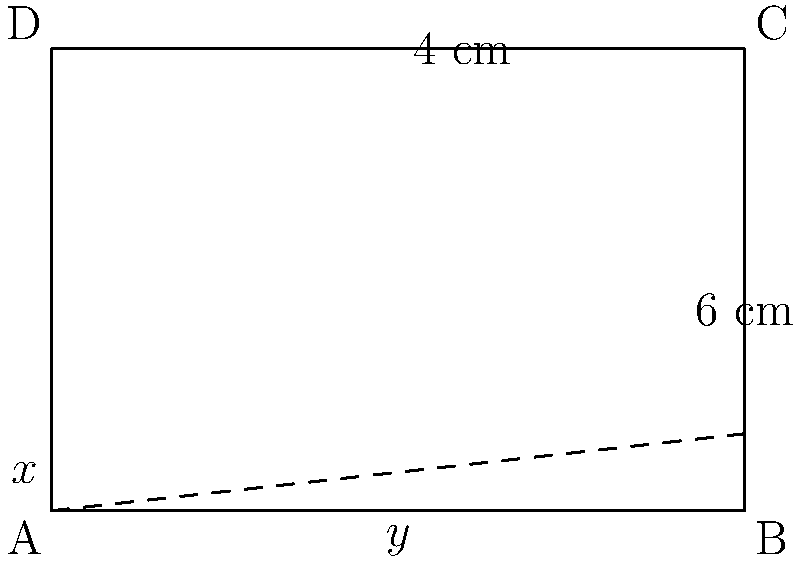A famous Renaissance artist used a rectangular canvas for one of their masterpieces. The canvas measures 6 cm in width and 4 cm in height. The artist divided the canvas into two sections using a horizontal line, creating a top section with height $x$ and a bottom section with height $y$. If the ratio of the areas of the top section to the bottom section is 1:2, what is the value of $x$? Let's approach this step-by-step:

1) The total height of the canvas is 4 cm, so we can write:
   $x + y = 4$

2) The width of the canvas is 6 cm for both sections.

3) The area of the top section is $6x$ cm², and the area of the bottom section is $6y$ cm².

4) We're told that the ratio of these areas is 1:2, which means:
   $\frac{6x}{6y} = \frac{1}{2}$

5) Simplifying this equation:
   $\frac{x}{y} = \frac{1}{2}$

6) Cross-multiplying:
   $2x = y$

7) Substituting this into our first equation:
   $x + 2x = 4$
   $3x = 4$

8) Solving for $x$:
   $x = \frac{4}{3}$

Therefore, the height of the top section, $x$, is $\frac{4}{3}$ cm.
Answer: $\frac{4}{3}$ cm 